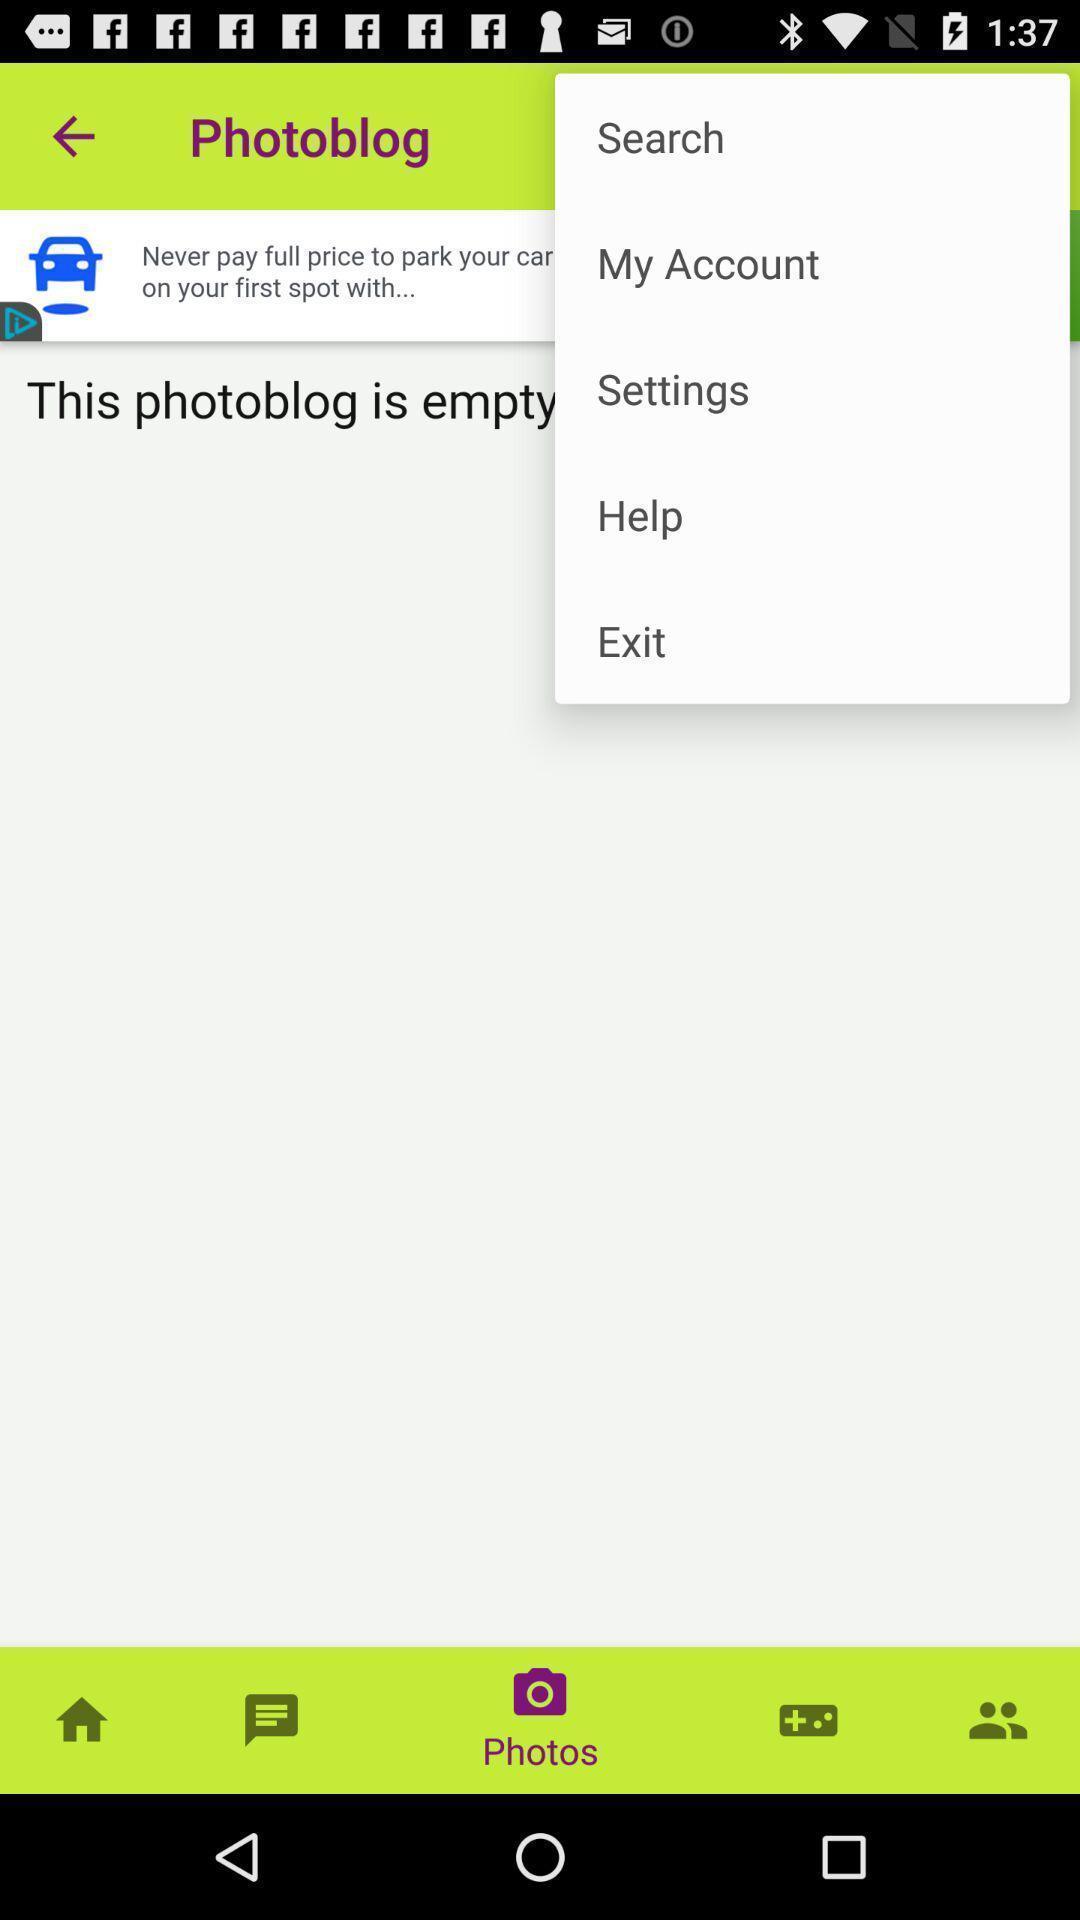Give me a summary of this screen capture. Pop up displaying options of a photo application. 